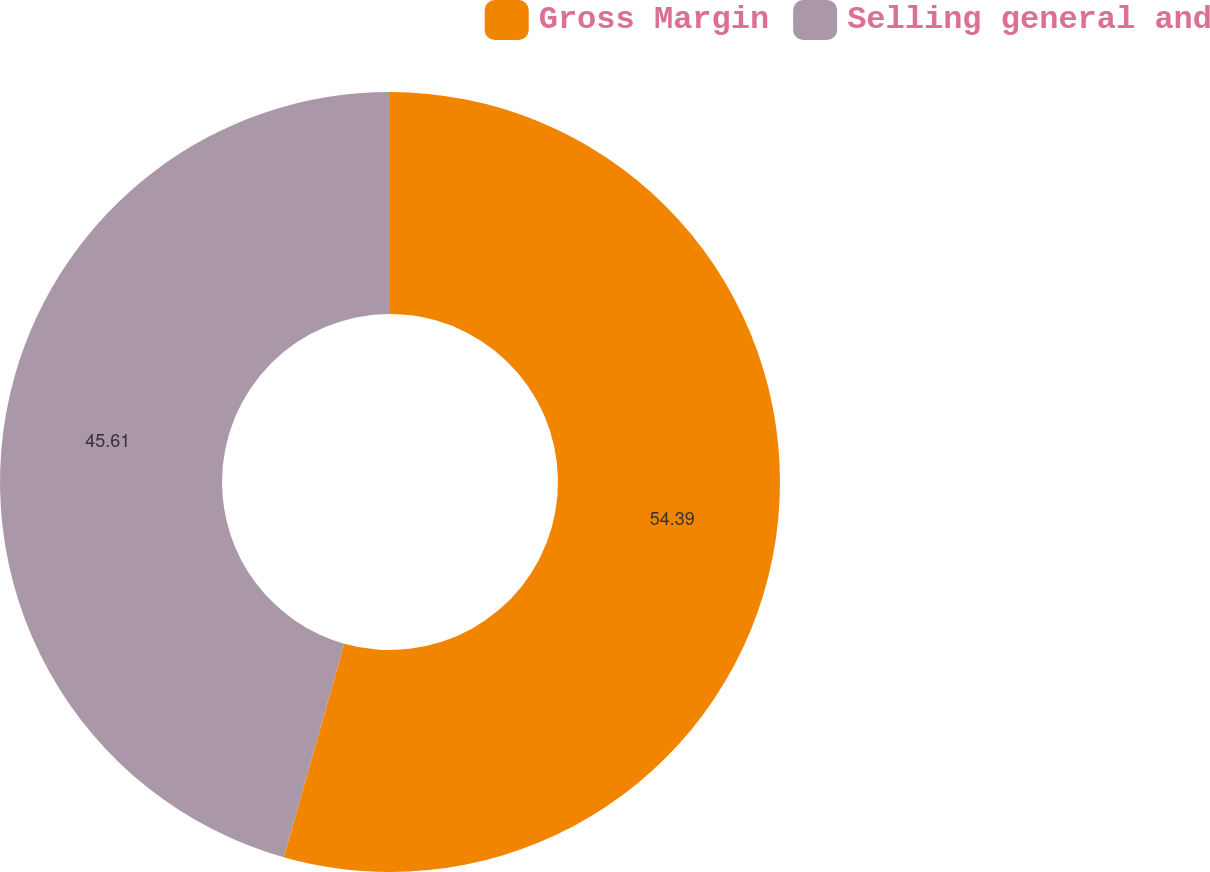Convert chart. <chart><loc_0><loc_0><loc_500><loc_500><pie_chart><fcel>Gross Margin<fcel>Selling general and<nl><fcel>54.39%<fcel>45.61%<nl></chart> 